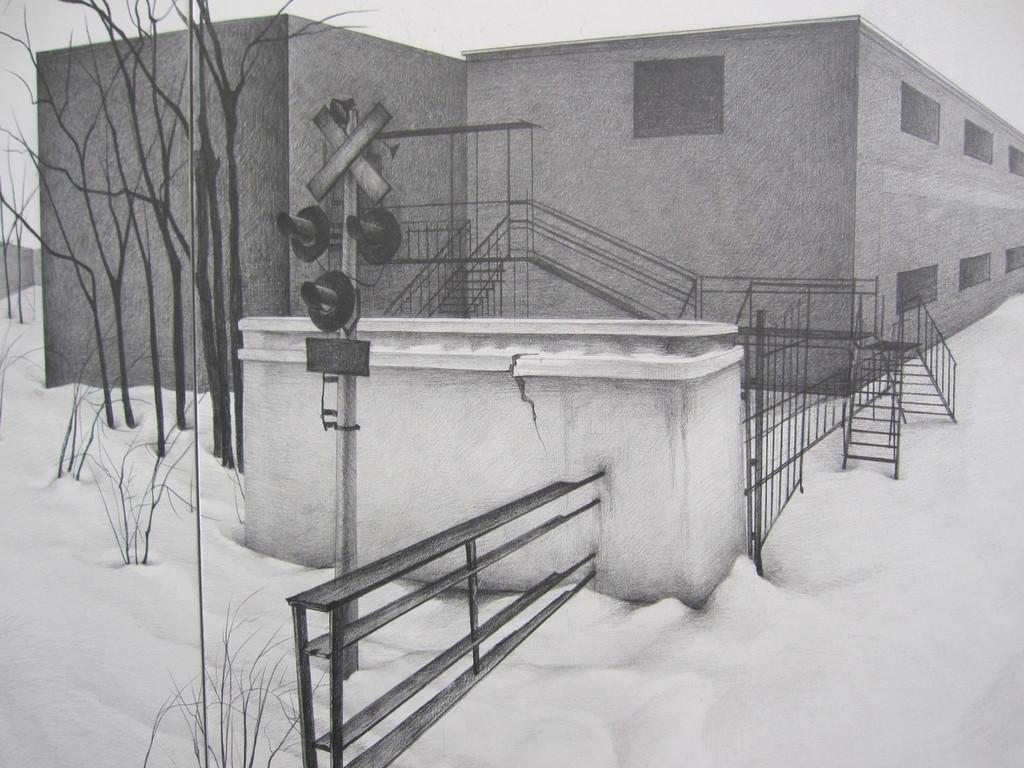What is located at the front of the image? There is a railing in the front of the image. What type of artwork is the image? The image is a painting. What is the weather condition depicted in the painting? There is snow on the ground in the painting. What type of structure is present in the painting? There is a building in the painting. What architectural feature can be seen in the painting? There are stairs in the painting. What type of vegetation is present in the painting? There are trees in the painting. How does the honey drip from the trees in the painting? There is no honey present in the painting; it features snow on the ground, a building, stairs, trees, and a railing. What type of brake system is installed on the stairs in the painting? There is no mention of a brake system in the painting; it only features stairs as an architectural feature. 